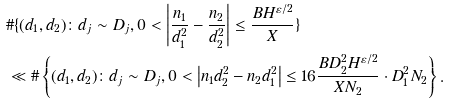<formula> <loc_0><loc_0><loc_500><loc_500>& \# \{ ( d _ { 1 } , d _ { 2 } ) \colon d _ { j } \sim D _ { j } , 0 < \left | \frac { n _ { 1 } } { d _ { 1 } ^ { 2 } } - \frac { n _ { 2 } } { d _ { 2 } ^ { 2 } } \right | \leq \frac { B H ^ { \varepsilon / 2 } } { X } \} \\ & \ll \# \left \{ ( d _ { 1 } , d _ { 2 } ) \colon d _ { j } \sim D _ { j } , 0 < \left | n _ { 1 } d _ { 2 } ^ { 2 } - n _ { 2 } d _ { 1 } ^ { 2 } \right | \leq 1 6 \frac { B D _ { 2 } ^ { 2 } H ^ { \varepsilon / 2 } } { X N _ { 2 } } \cdot D _ { 1 } ^ { 2 } N _ { 2 } \right \} .</formula> 